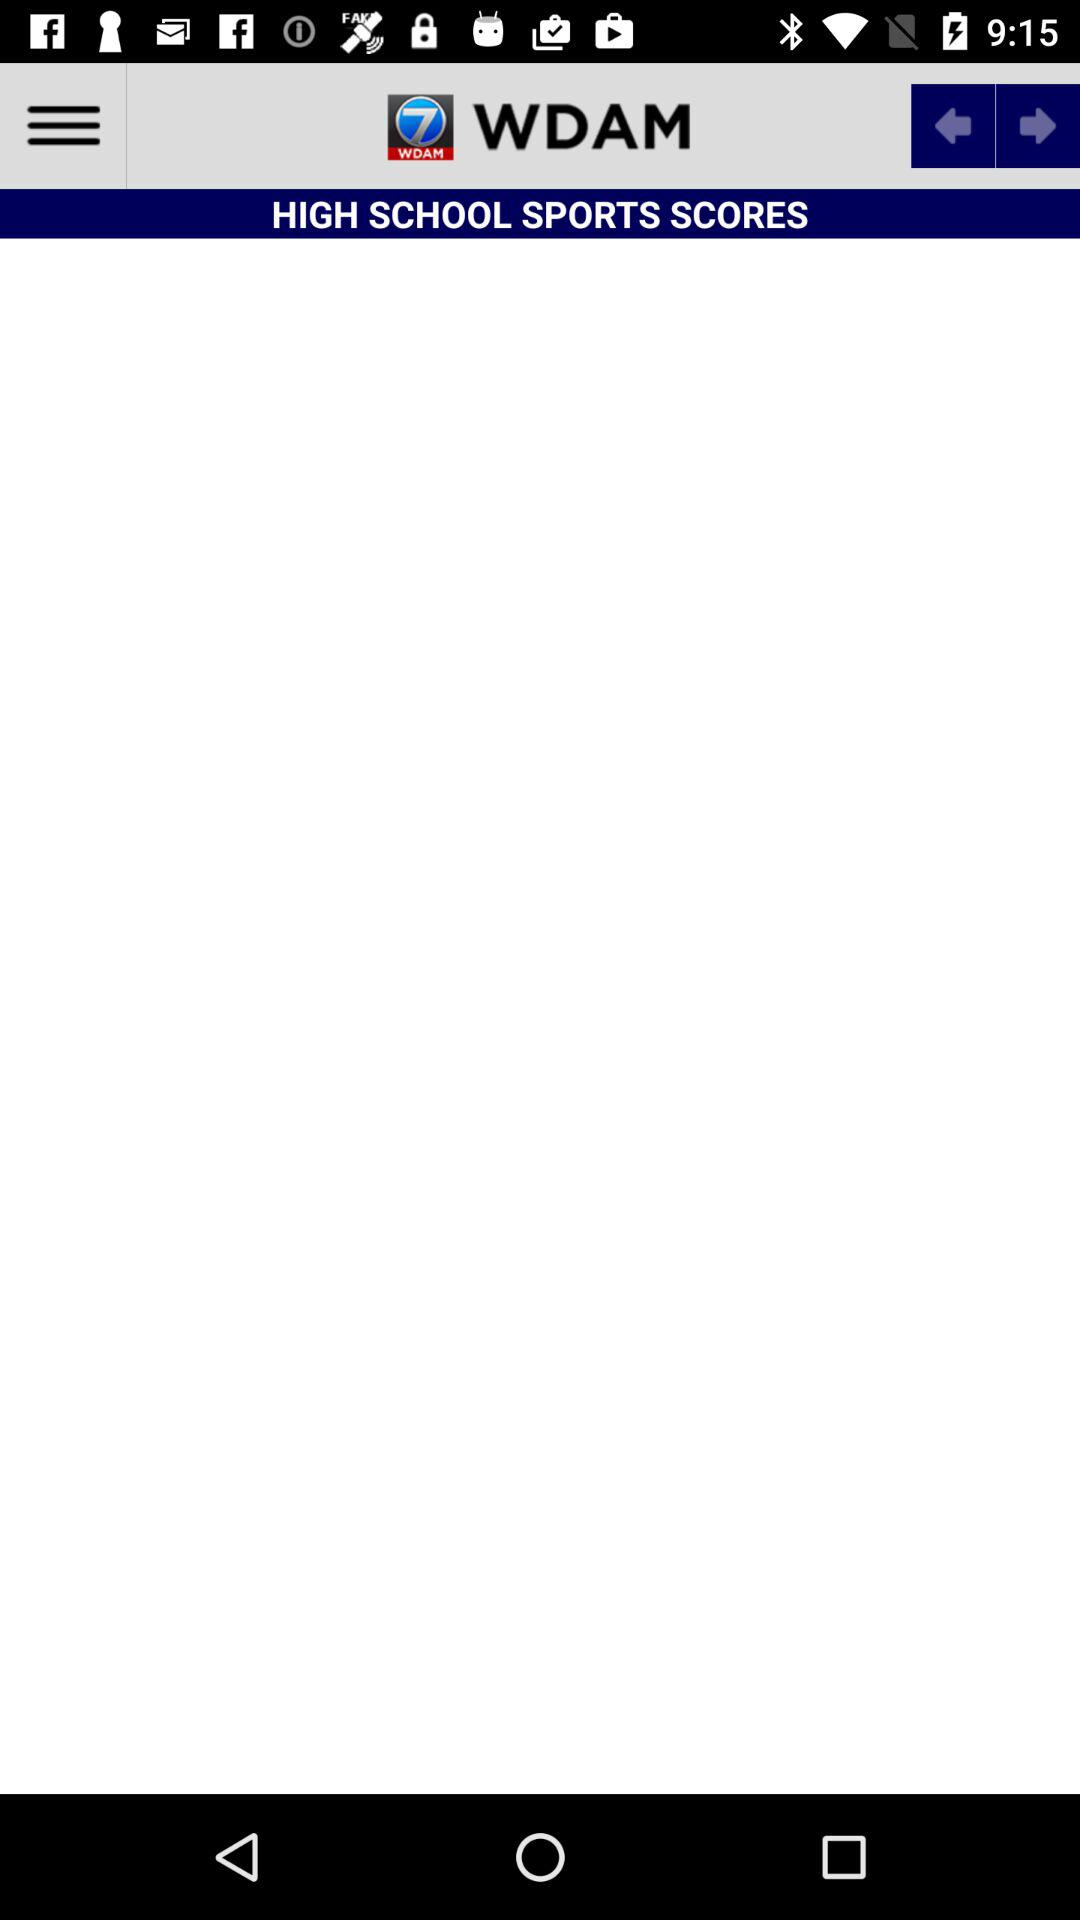What is the name of the application? The name of the application is "WDAM". 